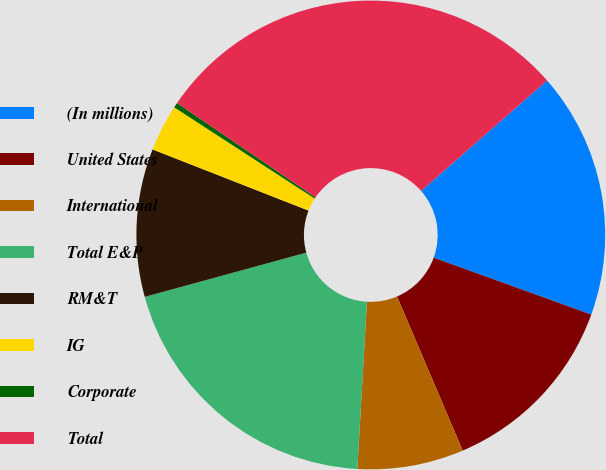Convert chart. <chart><loc_0><loc_0><loc_500><loc_500><pie_chart><fcel>(In millions)<fcel>United States<fcel>International<fcel>Total E&P<fcel>RM&T<fcel>IG<fcel>Corporate<fcel>Total<nl><fcel>16.97%<fcel>13.07%<fcel>7.33%<fcel>19.83%<fcel>10.2%<fcel>3.22%<fcel>0.35%<fcel>29.03%<nl></chart> 